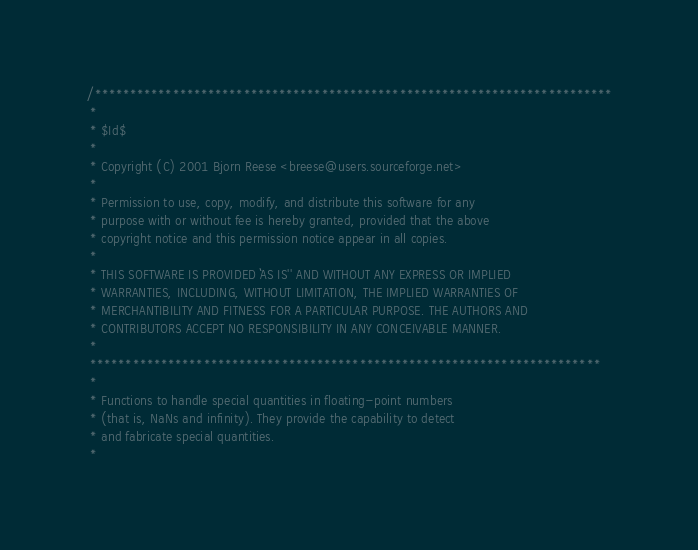<code> <loc_0><loc_0><loc_500><loc_500><_C_>/*************************************************************************
 *
 * $Id$
 *
 * Copyright (C) 2001 Bjorn Reese <breese@users.sourceforge.net>
 *
 * Permission to use, copy, modify, and distribute this software for any
 * purpose with or without fee is hereby granted, provided that the above
 * copyright notice and this permission notice appear in all copies.
 *
 * THIS SOFTWARE IS PROVIDED ``AS IS'' AND WITHOUT ANY EXPRESS OR IMPLIED
 * WARRANTIES, INCLUDING, WITHOUT LIMITATION, THE IMPLIED WARRANTIES OF
 * MERCHANTIBILITY AND FITNESS FOR A PARTICULAR PURPOSE. THE AUTHORS AND
 * CONTRIBUTORS ACCEPT NO RESPONSIBILITY IN ANY CONCEIVABLE MANNER.
 *
 ************************************************************************
 *
 * Functions to handle special quantities in floating-point numbers
 * (that is, NaNs and infinity). They provide the capability to detect
 * and fabricate special quantities.
 *</code> 